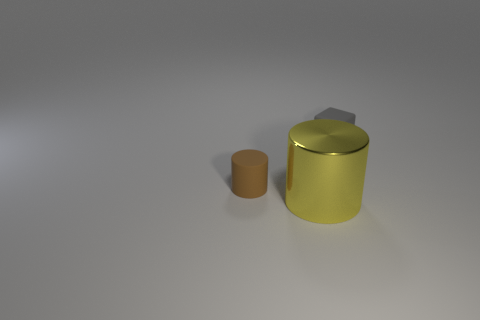Add 3 gray matte blocks. How many objects exist? 6 Subtract all cubes. How many objects are left? 2 Add 2 yellow objects. How many yellow objects exist? 3 Subtract 0 blue blocks. How many objects are left? 3 Subtract all green metal balls. Subtract all gray objects. How many objects are left? 2 Add 3 yellow shiny objects. How many yellow shiny objects are left? 4 